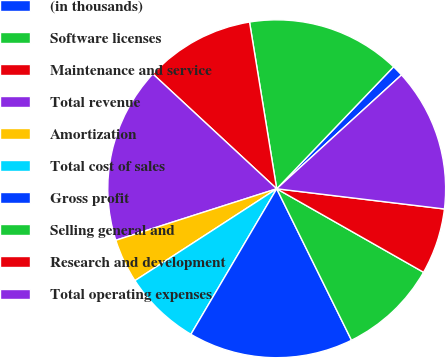Convert chart to OTSL. <chart><loc_0><loc_0><loc_500><loc_500><pie_chart><fcel>(in thousands)<fcel>Software licenses<fcel>Maintenance and service<fcel>Total revenue<fcel>Amortization<fcel>Total cost of sales<fcel>Gross profit<fcel>Selling general and<fcel>Research and development<fcel>Total operating expenses<nl><fcel>1.07%<fcel>14.73%<fcel>10.53%<fcel>16.83%<fcel>4.22%<fcel>7.37%<fcel>15.78%<fcel>9.47%<fcel>6.32%<fcel>13.68%<nl></chart> 